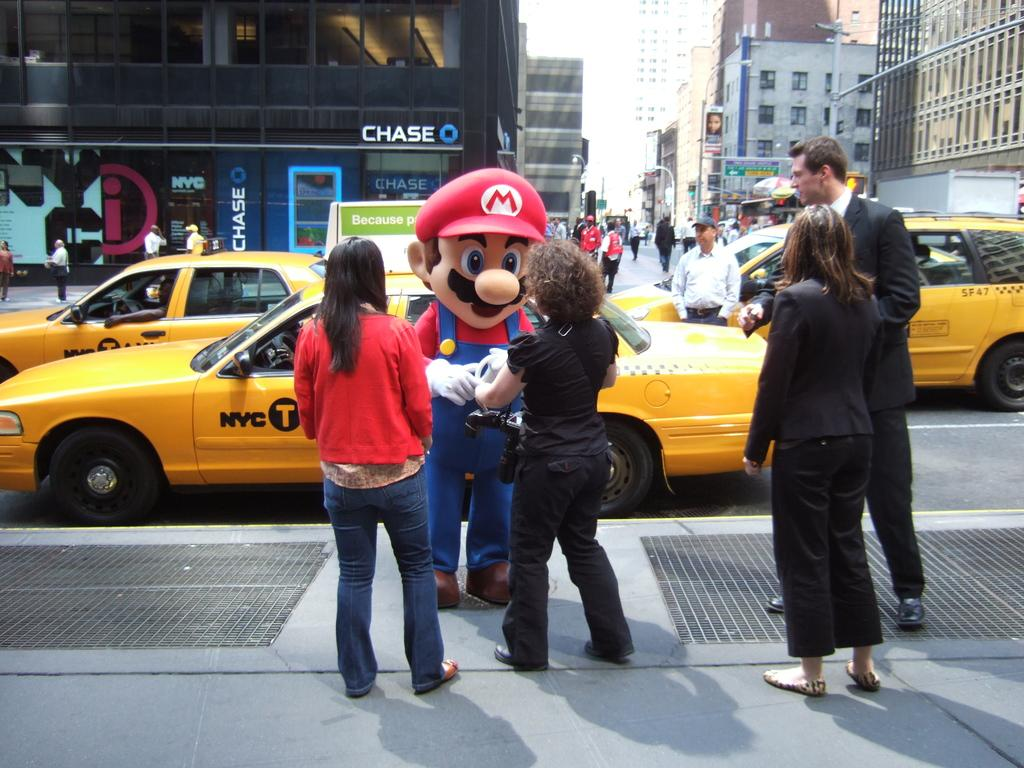Provide a one-sentence caption for the provided image. A person in Super Mario costume is interacting with people on the sidewalk while yellow cabs drive by behind. 